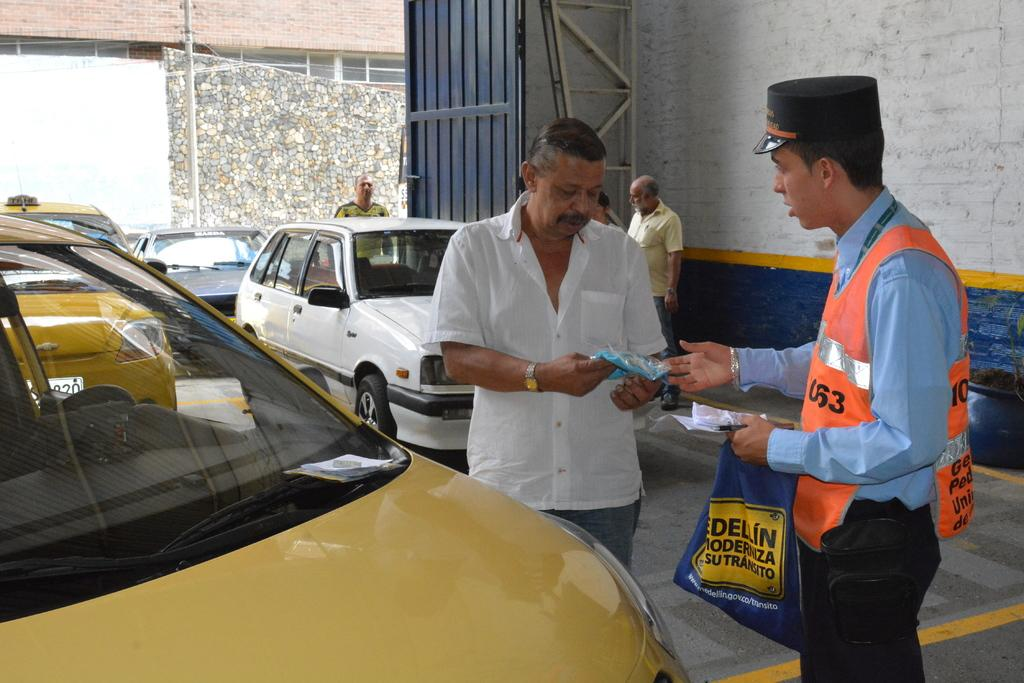How many persons are in the foreground of the picture? There are two persons in the foreground of the picture. What is located in the foreground of the picture alongside the persons? There is a car in the foreground of the picture. What can be seen in the background of the picture? There are cars, people, a gate, a wall, a building, and a current pole in the background of the picture. What type of jam is being spread on the nerve in the image? There is no jam or nerve present in the image; it features two persons, a car, and various background elements. 